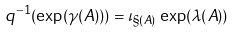<formula> <loc_0><loc_0><loc_500><loc_500>q ^ { - 1 } ( \exp ( \gamma ( A ) ) ) = \iota _ { \S ( A ) } \, \exp ( \lambda ( A ) )</formula> 